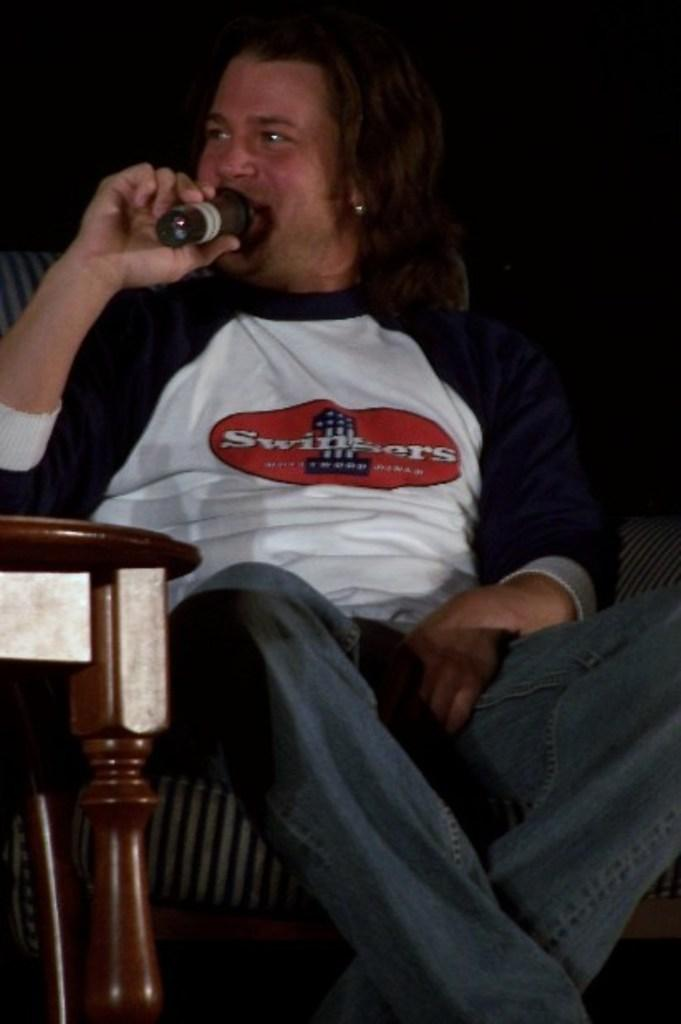What is the main subject of the image? The main subject of the image is a man. What is the man doing in the image? The man is sitting on a chair and holding a microphone with his right hand. What is the man's facial expression in the image? The man is smiling in the image. What type of seed can be seen growing on the man's head in the image? There is no seed or plant visible on the man's head in the image. 